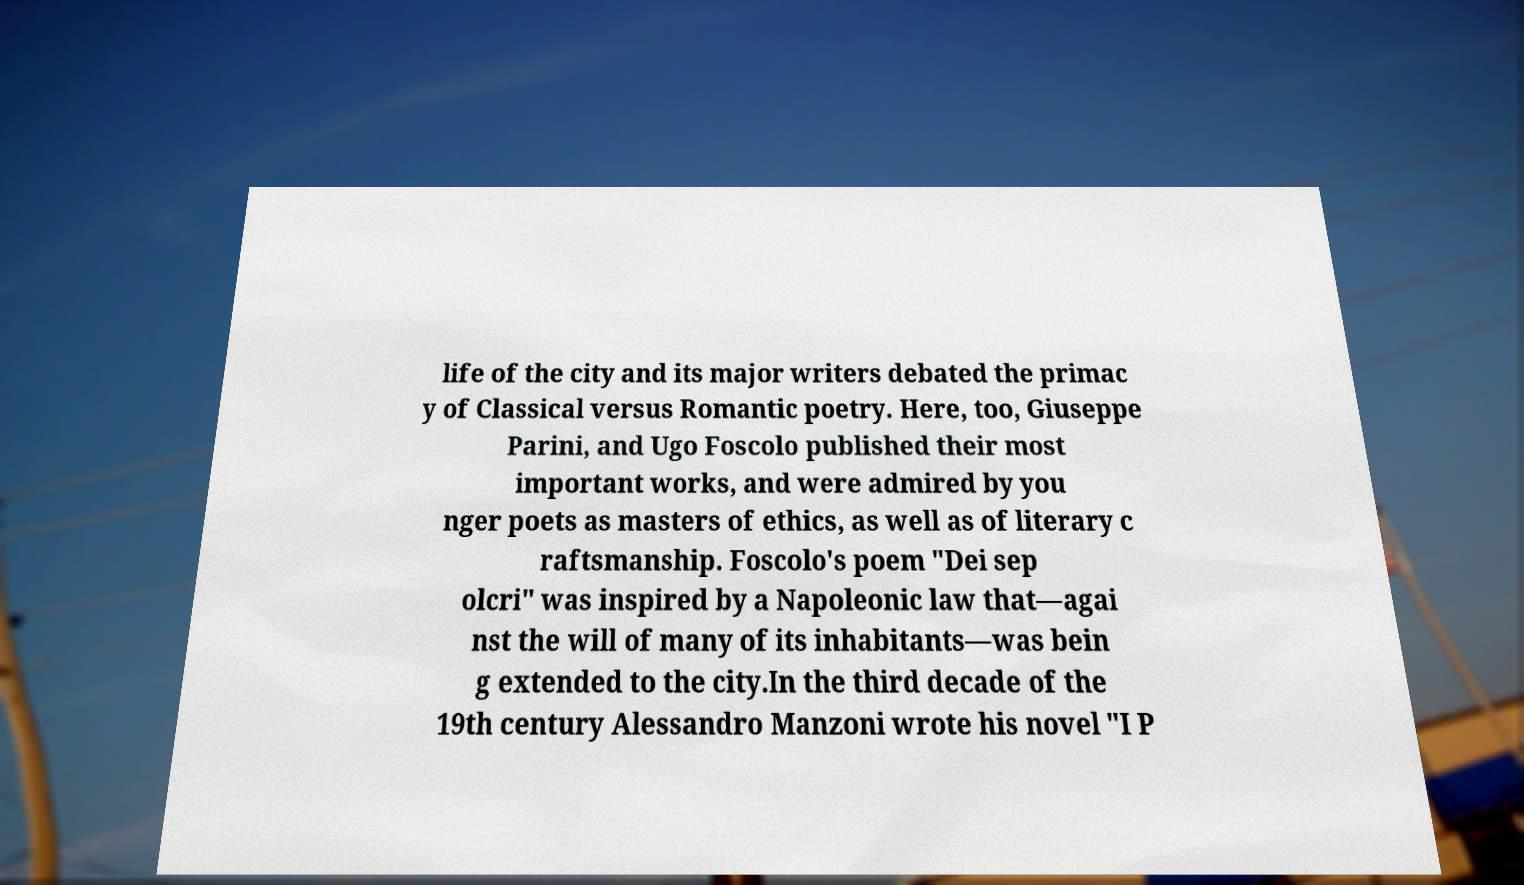Can you read and provide the text displayed in the image?This photo seems to have some interesting text. Can you extract and type it out for me? life of the city and its major writers debated the primac y of Classical versus Romantic poetry. Here, too, Giuseppe Parini, and Ugo Foscolo published their most important works, and were admired by you nger poets as masters of ethics, as well as of literary c raftsmanship. Foscolo's poem "Dei sep olcri" was inspired by a Napoleonic law that—agai nst the will of many of its inhabitants—was bein g extended to the city.In the third decade of the 19th century Alessandro Manzoni wrote his novel "I P 